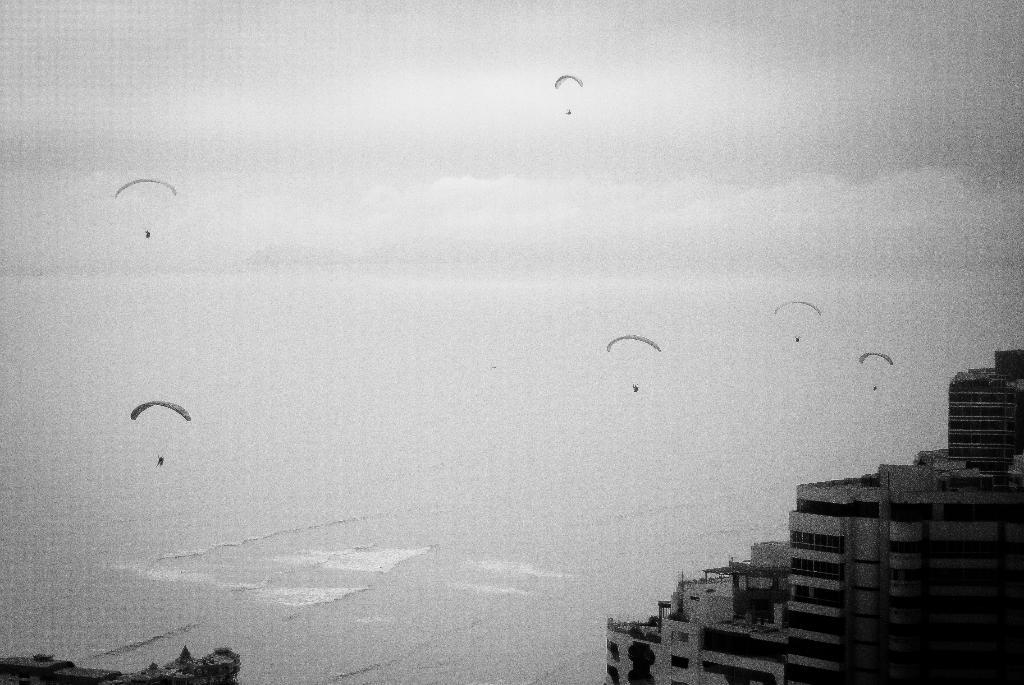What is the color scheme of the image? The image is black and white. What type of structures can be seen in the image? There are buildings in the image. What objects are present at the top of the image? There are parachutes at the top of the image. What is visible at the bottom of the image? There is water at the bottom of the image. How does the pollution affect the club in the image? There is no mention of pollution or a club in the image; it features buildings, parachutes, and water. 